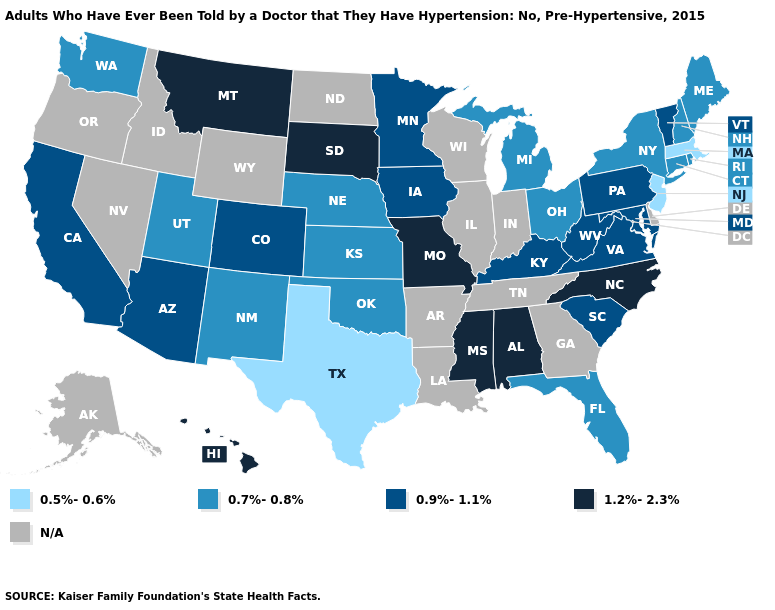What is the lowest value in the South?
Be succinct. 0.5%-0.6%. What is the lowest value in states that border Montana?
Keep it brief. 1.2%-2.3%. Which states have the lowest value in the USA?
Answer briefly. Massachusetts, New Jersey, Texas. What is the lowest value in the USA?
Short answer required. 0.5%-0.6%. What is the value of Wyoming?
Concise answer only. N/A. Name the states that have a value in the range 0.5%-0.6%?
Keep it brief. Massachusetts, New Jersey, Texas. Does Alabama have the lowest value in the USA?
Short answer required. No. Name the states that have a value in the range 1.2%-2.3%?
Keep it brief. Alabama, Hawaii, Mississippi, Missouri, Montana, North Carolina, South Dakota. Name the states that have a value in the range 1.2%-2.3%?
Quick response, please. Alabama, Hawaii, Mississippi, Missouri, Montana, North Carolina, South Dakota. Does the map have missing data?
Quick response, please. Yes. Name the states that have a value in the range N/A?
Be succinct. Alaska, Arkansas, Delaware, Georgia, Idaho, Illinois, Indiana, Louisiana, Nevada, North Dakota, Oregon, Tennessee, Wisconsin, Wyoming. Which states have the lowest value in the MidWest?
Concise answer only. Kansas, Michigan, Nebraska, Ohio. What is the highest value in the USA?
Concise answer only. 1.2%-2.3%. Among the states that border Missouri , which have the highest value?
Concise answer only. Iowa, Kentucky. 